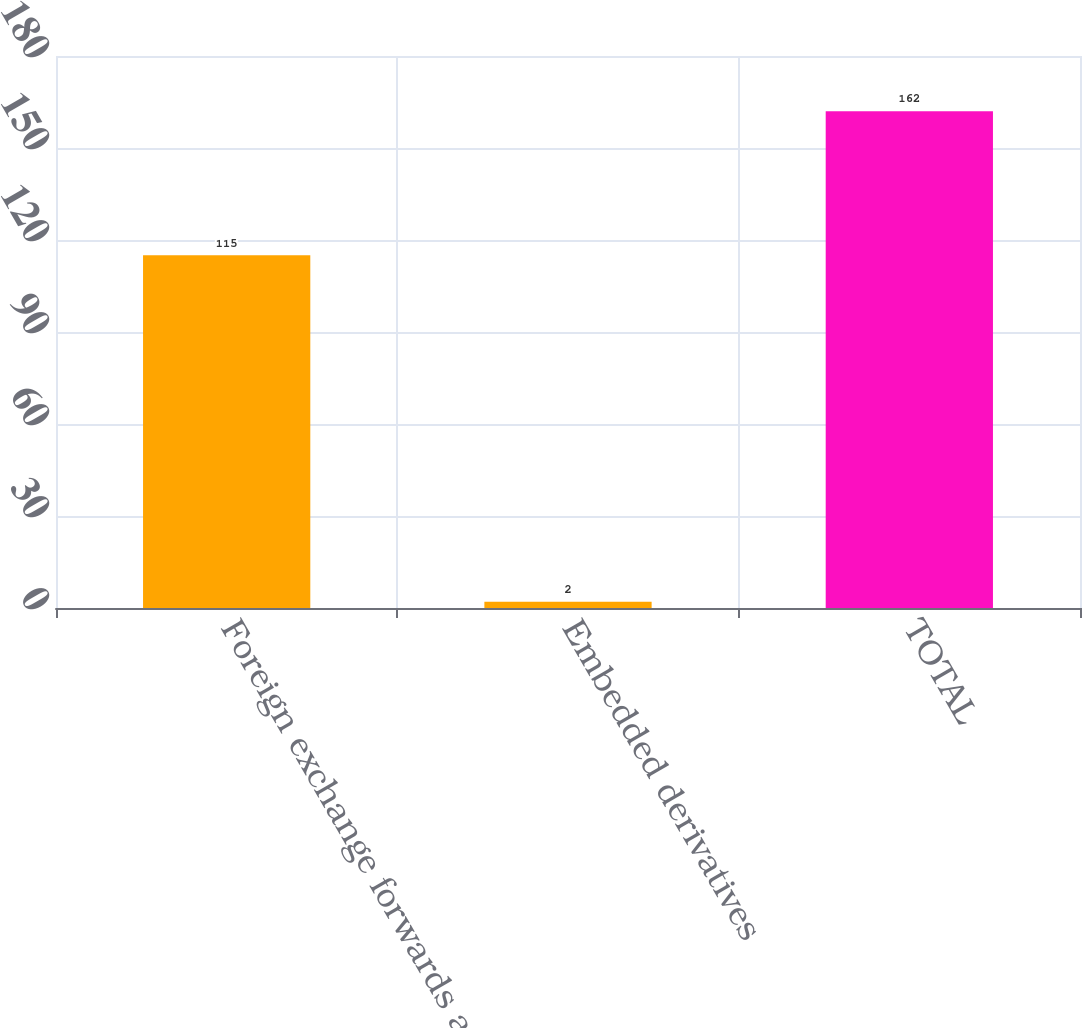Convert chart to OTSL. <chart><loc_0><loc_0><loc_500><loc_500><bar_chart><fcel>Foreign exchange forwards and<fcel>Embedded derivatives<fcel>TOTAL<nl><fcel>115<fcel>2<fcel>162<nl></chart> 